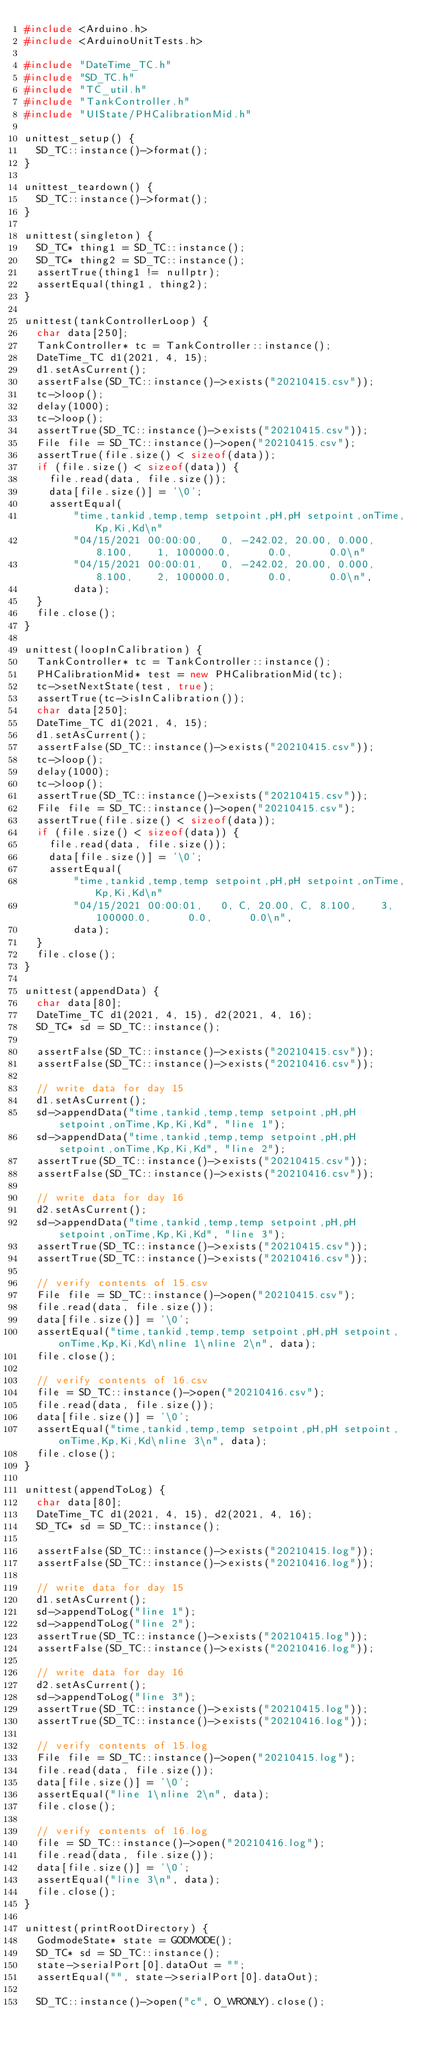Convert code to text. <code><loc_0><loc_0><loc_500><loc_500><_C++_>#include <Arduino.h>
#include <ArduinoUnitTests.h>

#include "DateTime_TC.h"
#include "SD_TC.h"
#include "TC_util.h"
#include "TankController.h"
#include "UIState/PHCalibrationMid.h"

unittest_setup() {
  SD_TC::instance()->format();
}

unittest_teardown() {
  SD_TC::instance()->format();
}

unittest(singleton) {
  SD_TC* thing1 = SD_TC::instance();
  SD_TC* thing2 = SD_TC::instance();
  assertTrue(thing1 != nullptr);
  assertEqual(thing1, thing2);
}

unittest(tankControllerLoop) {
  char data[250];
  TankController* tc = TankController::instance();
  DateTime_TC d1(2021, 4, 15);
  d1.setAsCurrent();
  assertFalse(SD_TC::instance()->exists("20210415.csv"));
  tc->loop();
  delay(1000);
  tc->loop();
  assertTrue(SD_TC::instance()->exists("20210415.csv"));
  File file = SD_TC::instance()->open("20210415.csv");
  assertTrue(file.size() < sizeof(data));
  if (file.size() < sizeof(data)) {
    file.read(data, file.size());
    data[file.size()] = '\0';
    assertEqual(
        "time,tankid,temp,temp setpoint,pH,pH setpoint,onTime,Kp,Ki,Kd\n"
        "04/15/2021 00:00:00,   0, -242.02, 20.00, 0.000, 8.100,    1, 100000.0,      0.0,      0.0\n"
        "04/15/2021 00:00:01,   0, -242.02, 20.00, 0.000, 8.100,    2, 100000.0,      0.0,      0.0\n",
        data);
  }
  file.close();
}

unittest(loopInCalibration) {
  TankController* tc = TankController::instance();
  PHCalibrationMid* test = new PHCalibrationMid(tc);
  tc->setNextState(test, true);
  assertTrue(tc->isInCalibration());
  char data[250];
  DateTime_TC d1(2021, 4, 15);
  d1.setAsCurrent();
  assertFalse(SD_TC::instance()->exists("20210415.csv"));
  tc->loop();
  delay(1000);
  tc->loop();
  assertTrue(SD_TC::instance()->exists("20210415.csv"));
  File file = SD_TC::instance()->open("20210415.csv");
  assertTrue(file.size() < sizeof(data));
  if (file.size() < sizeof(data)) {
    file.read(data, file.size());
    data[file.size()] = '\0';
    assertEqual(
        "time,tankid,temp,temp setpoint,pH,pH setpoint,onTime,Kp,Ki,Kd\n"
        "04/15/2021 00:00:01,   0, C, 20.00, C, 8.100,    3, 100000.0,      0.0,      0.0\n",
        data);
  }
  file.close();
}

unittest(appendData) {
  char data[80];
  DateTime_TC d1(2021, 4, 15), d2(2021, 4, 16);
  SD_TC* sd = SD_TC::instance();

  assertFalse(SD_TC::instance()->exists("20210415.csv"));
  assertFalse(SD_TC::instance()->exists("20210416.csv"));

  // write data for day 15
  d1.setAsCurrent();
  sd->appendData("time,tankid,temp,temp setpoint,pH,pH setpoint,onTime,Kp,Ki,Kd", "line 1");
  sd->appendData("time,tankid,temp,temp setpoint,pH,pH setpoint,onTime,Kp,Ki,Kd", "line 2");
  assertTrue(SD_TC::instance()->exists("20210415.csv"));
  assertFalse(SD_TC::instance()->exists("20210416.csv"));

  // write data for day 16
  d2.setAsCurrent();
  sd->appendData("time,tankid,temp,temp setpoint,pH,pH setpoint,onTime,Kp,Ki,Kd", "line 3");
  assertTrue(SD_TC::instance()->exists("20210415.csv"));
  assertTrue(SD_TC::instance()->exists("20210416.csv"));

  // verify contents of 15.csv
  File file = SD_TC::instance()->open("20210415.csv");
  file.read(data, file.size());
  data[file.size()] = '\0';
  assertEqual("time,tankid,temp,temp setpoint,pH,pH setpoint,onTime,Kp,Ki,Kd\nline 1\nline 2\n", data);
  file.close();

  // verify contents of 16.csv
  file = SD_TC::instance()->open("20210416.csv");
  file.read(data, file.size());
  data[file.size()] = '\0';
  assertEqual("time,tankid,temp,temp setpoint,pH,pH setpoint,onTime,Kp,Ki,Kd\nline 3\n", data);
  file.close();
}

unittest(appendToLog) {
  char data[80];
  DateTime_TC d1(2021, 4, 15), d2(2021, 4, 16);
  SD_TC* sd = SD_TC::instance();

  assertFalse(SD_TC::instance()->exists("20210415.log"));
  assertFalse(SD_TC::instance()->exists("20210416.log"));

  // write data for day 15
  d1.setAsCurrent();
  sd->appendToLog("line 1");
  sd->appendToLog("line 2");
  assertTrue(SD_TC::instance()->exists("20210415.log"));
  assertFalse(SD_TC::instance()->exists("20210416.log"));

  // write data for day 16
  d2.setAsCurrent();
  sd->appendToLog("line 3");
  assertTrue(SD_TC::instance()->exists("20210415.log"));
  assertTrue(SD_TC::instance()->exists("20210416.log"));

  // verify contents of 15.log
  File file = SD_TC::instance()->open("20210415.log");
  file.read(data, file.size());
  data[file.size()] = '\0';
  assertEqual("line 1\nline 2\n", data);
  file.close();

  // verify contents of 16.log
  file = SD_TC::instance()->open("20210416.log");
  file.read(data, file.size());
  data[file.size()] = '\0';
  assertEqual("line 3\n", data);
  file.close();
}

unittest(printRootDirectory) {
  GodmodeState* state = GODMODE();
  SD_TC* sd = SD_TC::instance();
  state->serialPort[0].dataOut = "";
  assertEqual("", state->serialPort[0].dataOut);

  SD_TC::instance()->open("c", O_WRONLY).close();</code> 